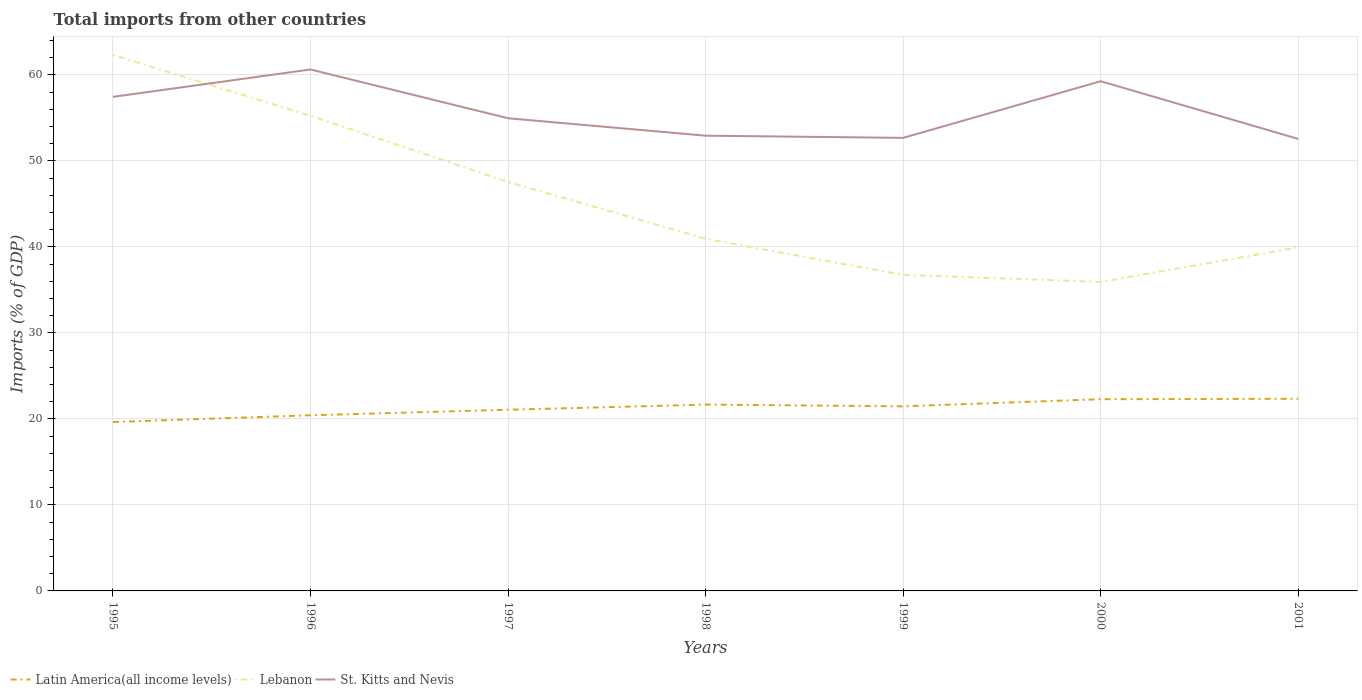Does the line corresponding to Lebanon intersect with the line corresponding to St. Kitts and Nevis?
Ensure brevity in your answer.  Yes. Across all years, what is the maximum total imports in St. Kitts and Nevis?
Keep it short and to the point. 52.56. In which year was the total imports in St. Kitts and Nevis maximum?
Your answer should be compact. 2001. What is the total total imports in St. Kitts and Nevis in the graph?
Your response must be concise. -4.31. What is the difference between the highest and the second highest total imports in Latin America(all income levels)?
Ensure brevity in your answer.  2.7. What is the difference between the highest and the lowest total imports in Lebanon?
Offer a very short reply. 3. Is the total imports in St. Kitts and Nevis strictly greater than the total imports in Lebanon over the years?
Provide a succinct answer. No. How many years are there in the graph?
Your answer should be very brief. 7. Where does the legend appear in the graph?
Make the answer very short. Bottom left. How many legend labels are there?
Your response must be concise. 3. What is the title of the graph?
Your answer should be compact. Total imports from other countries. What is the label or title of the Y-axis?
Provide a short and direct response. Imports (% of GDP). What is the Imports (% of GDP) of Latin America(all income levels) in 1995?
Ensure brevity in your answer.  19.64. What is the Imports (% of GDP) of Lebanon in 1995?
Provide a short and direct response. 62.33. What is the Imports (% of GDP) of St. Kitts and Nevis in 1995?
Your response must be concise. 57.45. What is the Imports (% of GDP) in Latin America(all income levels) in 1996?
Ensure brevity in your answer.  20.43. What is the Imports (% of GDP) of Lebanon in 1996?
Offer a terse response. 55.25. What is the Imports (% of GDP) in St. Kitts and Nevis in 1996?
Make the answer very short. 60.64. What is the Imports (% of GDP) in Latin America(all income levels) in 1997?
Your answer should be very brief. 21.07. What is the Imports (% of GDP) in Lebanon in 1997?
Offer a terse response. 47.55. What is the Imports (% of GDP) in St. Kitts and Nevis in 1997?
Make the answer very short. 54.96. What is the Imports (% of GDP) in Latin America(all income levels) in 1998?
Your answer should be very brief. 21.67. What is the Imports (% of GDP) in Lebanon in 1998?
Ensure brevity in your answer.  40.95. What is the Imports (% of GDP) in St. Kitts and Nevis in 1998?
Keep it short and to the point. 52.94. What is the Imports (% of GDP) in Latin America(all income levels) in 1999?
Offer a very short reply. 21.47. What is the Imports (% of GDP) in Lebanon in 1999?
Provide a short and direct response. 36.75. What is the Imports (% of GDP) of St. Kitts and Nevis in 1999?
Offer a very short reply. 52.68. What is the Imports (% of GDP) of Latin America(all income levels) in 2000?
Ensure brevity in your answer.  22.3. What is the Imports (% of GDP) of Lebanon in 2000?
Provide a short and direct response. 35.94. What is the Imports (% of GDP) of St. Kitts and Nevis in 2000?
Ensure brevity in your answer.  59.27. What is the Imports (% of GDP) of Latin America(all income levels) in 2001?
Offer a very short reply. 22.34. What is the Imports (% of GDP) of Lebanon in 2001?
Offer a terse response. 39.95. What is the Imports (% of GDP) in St. Kitts and Nevis in 2001?
Offer a terse response. 52.56. Across all years, what is the maximum Imports (% of GDP) of Latin America(all income levels)?
Provide a short and direct response. 22.34. Across all years, what is the maximum Imports (% of GDP) in Lebanon?
Make the answer very short. 62.33. Across all years, what is the maximum Imports (% of GDP) of St. Kitts and Nevis?
Offer a terse response. 60.64. Across all years, what is the minimum Imports (% of GDP) in Latin America(all income levels)?
Provide a short and direct response. 19.64. Across all years, what is the minimum Imports (% of GDP) in Lebanon?
Your answer should be very brief. 35.94. Across all years, what is the minimum Imports (% of GDP) of St. Kitts and Nevis?
Make the answer very short. 52.56. What is the total Imports (% of GDP) of Latin America(all income levels) in the graph?
Give a very brief answer. 148.91. What is the total Imports (% of GDP) of Lebanon in the graph?
Offer a terse response. 318.73. What is the total Imports (% of GDP) in St. Kitts and Nevis in the graph?
Make the answer very short. 390.51. What is the difference between the Imports (% of GDP) in Latin America(all income levels) in 1995 and that in 1996?
Offer a terse response. -0.78. What is the difference between the Imports (% of GDP) in Lebanon in 1995 and that in 1996?
Your response must be concise. 7.08. What is the difference between the Imports (% of GDP) in St. Kitts and Nevis in 1995 and that in 1996?
Ensure brevity in your answer.  -3.18. What is the difference between the Imports (% of GDP) of Latin America(all income levels) in 1995 and that in 1997?
Offer a very short reply. -1.43. What is the difference between the Imports (% of GDP) of Lebanon in 1995 and that in 1997?
Ensure brevity in your answer.  14.77. What is the difference between the Imports (% of GDP) of St. Kitts and Nevis in 1995 and that in 1997?
Keep it short and to the point. 2.49. What is the difference between the Imports (% of GDP) of Latin America(all income levels) in 1995 and that in 1998?
Your answer should be very brief. -2.02. What is the difference between the Imports (% of GDP) in Lebanon in 1995 and that in 1998?
Provide a short and direct response. 21.38. What is the difference between the Imports (% of GDP) in St. Kitts and Nevis in 1995 and that in 1998?
Your response must be concise. 4.52. What is the difference between the Imports (% of GDP) of Latin America(all income levels) in 1995 and that in 1999?
Your answer should be compact. -1.82. What is the difference between the Imports (% of GDP) of Lebanon in 1995 and that in 1999?
Make the answer very short. 25.58. What is the difference between the Imports (% of GDP) of St. Kitts and Nevis in 1995 and that in 1999?
Provide a short and direct response. 4.77. What is the difference between the Imports (% of GDP) in Latin America(all income levels) in 1995 and that in 2000?
Keep it short and to the point. -2.65. What is the difference between the Imports (% of GDP) in Lebanon in 1995 and that in 2000?
Provide a short and direct response. 26.39. What is the difference between the Imports (% of GDP) in St. Kitts and Nevis in 1995 and that in 2000?
Ensure brevity in your answer.  -1.82. What is the difference between the Imports (% of GDP) in Latin America(all income levels) in 1995 and that in 2001?
Offer a terse response. -2.7. What is the difference between the Imports (% of GDP) in Lebanon in 1995 and that in 2001?
Keep it short and to the point. 22.38. What is the difference between the Imports (% of GDP) in St. Kitts and Nevis in 1995 and that in 2001?
Offer a terse response. 4.89. What is the difference between the Imports (% of GDP) of Latin America(all income levels) in 1996 and that in 1997?
Keep it short and to the point. -0.64. What is the difference between the Imports (% of GDP) of Lebanon in 1996 and that in 1997?
Your answer should be very brief. 7.7. What is the difference between the Imports (% of GDP) of St. Kitts and Nevis in 1996 and that in 1997?
Give a very brief answer. 5.67. What is the difference between the Imports (% of GDP) in Latin America(all income levels) in 1996 and that in 1998?
Keep it short and to the point. -1.24. What is the difference between the Imports (% of GDP) of Lebanon in 1996 and that in 1998?
Give a very brief answer. 14.3. What is the difference between the Imports (% of GDP) in St. Kitts and Nevis in 1996 and that in 1998?
Ensure brevity in your answer.  7.7. What is the difference between the Imports (% of GDP) in Latin America(all income levels) in 1996 and that in 1999?
Your answer should be compact. -1.04. What is the difference between the Imports (% of GDP) of Lebanon in 1996 and that in 1999?
Provide a short and direct response. 18.5. What is the difference between the Imports (% of GDP) of St. Kitts and Nevis in 1996 and that in 1999?
Make the answer very short. 7.95. What is the difference between the Imports (% of GDP) of Latin America(all income levels) in 1996 and that in 2000?
Make the answer very short. -1.87. What is the difference between the Imports (% of GDP) in Lebanon in 1996 and that in 2000?
Give a very brief answer. 19.31. What is the difference between the Imports (% of GDP) of St. Kitts and Nevis in 1996 and that in 2000?
Your response must be concise. 1.37. What is the difference between the Imports (% of GDP) in Latin America(all income levels) in 1996 and that in 2001?
Provide a succinct answer. -1.92. What is the difference between the Imports (% of GDP) of Lebanon in 1996 and that in 2001?
Ensure brevity in your answer.  15.3. What is the difference between the Imports (% of GDP) of St. Kitts and Nevis in 1996 and that in 2001?
Offer a very short reply. 8.07. What is the difference between the Imports (% of GDP) of Latin America(all income levels) in 1997 and that in 1998?
Offer a very short reply. -0.6. What is the difference between the Imports (% of GDP) of Lebanon in 1997 and that in 1998?
Provide a succinct answer. 6.6. What is the difference between the Imports (% of GDP) in St. Kitts and Nevis in 1997 and that in 1998?
Your answer should be compact. 2.03. What is the difference between the Imports (% of GDP) of Latin America(all income levels) in 1997 and that in 1999?
Provide a short and direct response. -0.4. What is the difference between the Imports (% of GDP) in Lebanon in 1997 and that in 1999?
Your answer should be compact. 10.8. What is the difference between the Imports (% of GDP) in St. Kitts and Nevis in 1997 and that in 1999?
Your answer should be compact. 2.28. What is the difference between the Imports (% of GDP) in Latin America(all income levels) in 1997 and that in 2000?
Your answer should be very brief. -1.23. What is the difference between the Imports (% of GDP) in Lebanon in 1997 and that in 2000?
Provide a short and direct response. 11.62. What is the difference between the Imports (% of GDP) in St. Kitts and Nevis in 1997 and that in 2000?
Your response must be concise. -4.31. What is the difference between the Imports (% of GDP) of Latin America(all income levels) in 1997 and that in 2001?
Your response must be concise. -1.28. What is the difference between the Imports (% of GDP) in Lebanon in 1997 and that in 2001?
Keep it short and to the point. 7.6. What is the difference between the Imports (% of GDP) of St. Kitts and Nevis in 1997 and that in 2001?
Your answer should be compact. 2.4. What is the difference between the Imports (% of GDP) of Latin America(all income levels) in 1998 and that in 1999?
Offer a very short reply. 0.2. What is the difference between the Imports (% of GDP) in Lebanon in 1998 and that in 1999?
Offer a terse response. 4.2. What is the difference between the Imports (% of GDP) in St. Kitts and Nevis in 1998 and that in 1999?
Ensure brevity in your answer.  0.25. What is the difference between the Imports (% of GDP) of Latin America(all income levels) in 1998 and that in 2000?
Your answer should be compact. -0.63. What is the difference between the Imports (% of GDP) of Lebanon in 1998 and that in 2000?
Offer a terse response. 5.02. What is the difference between the Imports (% of GDP) in St. Kitts and Nevis in 1998 and that in 2000?
Offer a very short reply. -6.33. What is the difference between the Imports (% of GDP) in Latin America(all income levels) in 1998 and that in 2001?
Provide a short and direct response. -0.68. What is the difference between the Imports (% of GDP) of Lebanon in 1998 and that in 2001?
Provide a succinct answer. 1. What is the difference between the Imports (% of GDP) in St. Kitts and Nevis in 1998 and that in 2001?
Offer a very short reply. 0.37. What is the difference between the Imports (% of GDP) of Latin America(all income levels) in 1999 and that in 2000?
Ensure brevity in your answer.  -0.83. What is the difference between the Imports (% of GDP) of Lebanon in 1999 and that in 2000?
Keep it short and to the point. 0.81. What is the difference between the Imports (% of GDP) of St. Kitts and Nevis in 1999 and that in 2000?
Offer a terse response. -6.59. What is the difference between the Imports (% of GDP) in Latin America(all income levels) in 1999 and that in 2001?
Make the answer very short. -0.88. What is the difference between the Imports (% of GDP) of Lebanon in 1999 and that in 2001?
Your response must be concise. -3.2. What is the difference between the Imports (% of GDP) in St. Kitts and Nevis in 1999 and that in 2001?
Your answer should be very brief. 0.12. What is the difference between the Imports (% of GDP) in Latin America(all income levels) in 2000 and that in 2001?
Provide a succinct answer. -0.05. What is the difference between the Imports (% of GDP) in Lebanon in 2000 and that in 2001?
Provide a short and direct response. -4.01. What is the difference between the Imports (% of GDP) of St. Kitts and Nevis in 2000 and that in 2001?
Offer a very short reply. 6.71. What is the difference between the Imports (% of GDP) in Latin America(all income levels) in 1995 and the Imports (% of GDP) in Lebanon in 1996?
Your answer should be very brief. -35.61. What is the difference between the Imports (% of GDP) in Latin America(all income levels) in 1995 and the Imports (% of GDP) in St. Kitts and Nevis in 1996?
Make the answer very short. -41. What is the difference between the Imports (% of GDP) of Lebanon in 1995 and the Imports (% of GDP) of St. Kitts and Nevis in 1996?
Ensure brevity in your answer.  1.69. What is the difference between the Imports (% of GDP) in Latin America(all income levels) in 1995 and the Imports (% of GDP) in Lebanon in 1997?
Your answer should be compact. -27.91. What is the difference between the Imports (% of GDP) in Latin America(all income levels) in 1995 and the Imports (% of GDP) in St. Kitts and Nevis in 1997?
Offer a very short reply. -35.32. What is the difference between the Imports (% of GDP) in Lebanon in 1995 and the Imports (% of GDP) in St. Kitts and Nevis in 1997?
Your answer should be very brief. 7.36. What is the difference between the Imports (% of GDP) of Latin America(all income levels) in 1995 and the Imports (% of GDP) of Lebanon in 1998?
Give a very brief answer. -21.31. What is the difference between the Imports (% of GDP) of Latin America(all income levels) in 1995 and the Imports (% of GDP) of St. Kitts and Nevis in 1998?
Your response must be concise. -33.3. What is the difference between the Imports (% of GDP) in Lebanon in 1995 and the Imports (% of GDP) in St. Kitts and Nevis in 1998?
Keep it short and to the point. 9.39. What is the difference between the Imports (% of GDP) in Latin America(all income levels) in 1995 and the Imports (% of GDP) in Lebanon in 1999?
Ensure brevity in your answer.  -17.11. What is the difference between the Imports (% of GDP) in Latin America(all income levels) in 1995 and the Imports (% of GDP) in St. Kitts and Nevis in 1999?
Make the answer very short. -33.04. What is the difference between the Imports (% of GDP) of Lebanon in 1995 and the Imports (% of GDP) of St. Kitts and Nevis in 1999?
Provide a short and direct response. 9.64. What is the difference between the Imports (% of GDP) in Latin America(all income levels) in 1995 and the Imports (% of GDP) in Lebanon in 2000?
Give a very brief answer. -16.3. What is the difference between the Imports (% of GDP) in Latin America(all income levels) in 1995 and the Imports (% of GDP) in St. Kitts and Nevis in 2000?
Ensure brevity in your answer.  -39.63. What is the difference between the Imports (% of GDP) of Lebanon in 1995 and the Imports (% of GDP) of St. Kitts and Nevis in 2000?
Ensure brevity in your answer.  3.06. What is the difference between the Imports (% of GDP) in Latin America(all income levels) in 1995 and the Imports (% of GDP) in Lebanon in 2001?
Provide a short and direct response. -20.31. What is the difference between the Imports (% of GDP) of Latin America(all income levels) in 1995 and the Imports (% of GDP) of St. Kitts and Nevis in 2001?
Offer a terse response. -32.92. What is the difference between the Imports (% of GDP) of Lebanon in 1995 and the Imports (% of GDP) of St. Kitts and Nevis in 2001?
Your answer should be compact. 9.77. What is the difference between the Imports (% of GDP) in Latin America(all income levels) in 1996 and the Imports (% of GDP) in Lebanon in 1997?
Ensure brevity in your answer.  -27.13. What is the difference between the Imports (% of GDP) in Latin America(all income levels) in 1996 and the Imports (% of GDP) in St. Kitts and Nevis in 1997?
Provide a short and direct response. -34.54. What is the difference between the Imports (% of GDP) of Lebanon in 1996 and the Imports (% of GDP) of St. Kitts and Nevis in 1997?
Keep it short and to the point. 0.29. What is the difference between the Imports (% of GDP) in Latin America(all income levels) in 1996 and the Imports (% of GDP) in Lebanon in 1998?
Your response must be concise. -20.53. What is the difference between the Imports (% of GDP) of Latin America(all income levels) in 1996 and the Imports (% of GDP) of St. Kitts and Nevis in 1998?
Offer a very short reply. -32.51. What is the difference between the Imports (% of GDP) of Lebanon in 1996 and the Imports (% of GDP) of St. Kitts and Nevis in 1998?
Offer a terse response. 2.31. What is the difference between the Imports (% of GDP) of Latin America(all income levels) in 1996 and the Imports (% of GDP) of Lebanon in 1999?
Make the answer very short. -16.32. What is the difference between the Imports (% of GDP) in Latin America(all income levels) in 1996 and the Imports (% of GDP) in St. Kitts and Nevis in 1999?
Give a very brief answer. -32.26. What is the difference between the Imports (% of GDP) of Lebanon in 1996 and the Imports (% of GDP) of St. Kitts and Nevis in 1999?
Make the answer very short. 2.57. What is the difference between the Imports (% of GDP) of Latin America(all income levels) in 1996 and the Imports (% of GDP) of Lebanon in 2000?
Provide a succinct answer. -15.51. What is the difference between the Imports (% of GDP) in Latin America(all income levels) in 1996 and the Imports (% of GDP) in St. Kitts and Nevis in 2000?
Your answer should be very brief. -38.84. What is the difference between the Imports (% of GDP) of Lebanon in 1996 and the Imports (% of GDP) of St. Kitts and Nevis in 2000?
Your answer should be very brief. -4.02. What is the difference between the Imports (% of GDP) in Latin America(all income levels) in 1996 and the Imports (% of GDP) in Lebanon in 2001?
Ensure brevity in your answer.  -19.53. What is the difference between the Imports (% of GDP) in Latin America(all income levels) in 1996 and the Imports (% of GDP) in St. Kitts and Nevis in 2001?
Provide a succinct answer. -32.14. What is the difference between the Imports (% of GDP) of Lebanon in 1996 and the Imports (% of GDP) of St. Kitts and Nevis in 2001?
Give a very brief answer. 2.69. What is the difference between the Imports (% of GDP) in Latin America(all income levels) in 1997 and the Imports (% of GDP) in Lebanon in 1998?
Offer a very short reply. -19.89. What is the difference between the Imports (% of GDP) of Latin America(all income levels) in 1997 and the Imports (% of GDP) of St. Kitts and Nevis in 1998?
Offer a very short reply. -31.87. What is the difference between the Imports (% of GDP) of Lebanon in 1997 and the Imports (% of GDP) of St. Kitts and Nevis in 1998?
Keep it short and to the point. -5.38. What is the difference between the Imports (% of GDP) of Latin America(all income levels) in 1997 and the Imports (% of GDP) of Lebanon in 1999?
Provide a short and direct response. -15.68. What is the difference between the Imports (% of GDP) in Latin America(all income levels) in 1997 and the Imports (% of GDP) in St. Kitts and Nevis in 1999?
Make the answer very short. -31.62. What is the difference between the Imports (% of GDP) in Lebanon in 1997 and the Imports (% of GDP) in St. Kitts and Nevis in 1999?
Make the answer very short. -5.13. What is the difference between the Imports (% of GDP) in Latin America(all income levels) in 1997 and the Imports (% of GDP) in Lebanon in 2000?
Provide a succinct answer. -14.87. What is the difference between the Imports (% of GDP) of Latin America(all income levels) in 1997 and the Imports (% of GDP) of St. Kitts and Nevis in 2000?
Offer a terse response. -38.2. What is the difference between the Imports (% of GDP) of Lebanon in 1997 and the Imports (% of GDP) of St. Kitts and Nevis in 2000?
Keep it short and to the point. -11.72. What is the difference between the Imports (% of GDP) of Latin America(all income levels) in 1997 and the Imports (% of GDP) of Lebanon in 2001?
Provide a short and direct response. -18.88. What is the difference between the Imports (% of GDP) of Latin America(all income levels) in 1997 and the Imports (% of GDP) of St. Kitts and Nevis in 2001?
Your answer should be very brief. -31.5. What is the difference between the Imports (% of GDP) of Lebanon in 1997 and the Imports (% of GDP) of St. Kitts and Nevis in 2001?
Make the answer very short. -5.01. What is the difference between the Imports (% of GDP) of Latin America(all income levels) in 1998 and the Imports (% of GDP) of Lebanon in 1999?
Offer a terse response. -15.08. What is the difference between the Imports (% of GDP) in Latin America(all income levels) in 1998 and the Imports (% of GDP) in St. Kitts and Nevis in 1999?
Offer a very short reply. -31.02. What is the difference between the Imports (% of GDP) in Lebanon in 1998 and the Imports (% of GDP) in St. Kitts and Nevis in 1999?
Ensure brevity in your answer.  -11.73. What is the difference between the Imports (% of GDP) of Latin America(all income levels) in 1998 and the Imports (% of GDP) of Lebanon in 2000?
Ensure brevity in your answer.  -14.27. What is the difference between the Imports (% of GDP) of Latin America(all income levels) in 1998 and the Imports (% of GDP) of St. Kitts and Nevis in 2000?
Provide a succinct answer. -37.6. What is the difference between the Imports (% of GDP) of Lebanon in 1998 and the Imports (% of GDP) of St. Kitts and Nevis in 2000?
Make the answer very short. -18.32. What is the difference between the Imports (% of GDP) in Latin America(all income levels) in 1998 and the Imports (% of GDP) in Lebanon in 2001?
Make the answer very short. -18.29. What is the difference between the Imports (% of GDP) of Latin America(all income levels) in 1998 and the Imports (% of GDP) of St. Kitts and Nevis in 2001?
Provide a succinct answer. -30.9. What is the difference between the Imports (% of GDP) of Lebanon in 1998 and the Imports (% of GDP) of St. Kitts and Nevis in 2001?
Offer a terse response. -11.61. What is the difference between the Imports (% of GDP) in Latin America(all income levels) in 1999 and the Imports (% of GDP) in Lebanon in 2000?
Ensure brevity in your answer.  -14.47. What is the difference between the Imports (% of GDP) of Latin America(all income levels) in 1999 and the Imports (% of GDP) of St. Kitts and Nevis in 2000?
Provide a short and direct response. -37.8. What is the difference between the Imports (% of GDP) in Lebanon in 1999 and the Imports (% of GDP) in St. Kitts and Nevis in 2000?
Ensure brevity in your answer.  -22.52. What is the difference between the Imports (% of GDP) of Latin America(all income levels) in 1999 and the Imports (% of GDP) of Lebanon in 2001?
Your response must be concise. -18.49. What is the difference between the Imports (% of GDP) of Latin America(all income levels) in 1999 and the Imports (% of GDP) of St. Kitts and Nevis in 2001?
Your answer should be compact. -31.1. What is the difference between the Imports (% of GDP) of Lebanon in 1999 and the Imports (% of GDP) of St. Kitts and Nevis in 2001?
Provide a succinct answer. -15.81. What is the difference between the Imports (% of GDP) of Latin America(all income levels) in 2000 and the Imports (% of GDP) of Lebanon in 2001?
Keep it short and to the point. -17.66. What is the difference between the Imports (% of GDP) of Latin America(all income levels) in 2000 and the Imports (% of GDP) of St. Kitts and Nevis in 2001?
Provide a succinct answer. -30.27. What is the difference between the Imports (% of GDP) of Lebanon in 2000 and the Imports (% of GDP) of St. Kitts and Nevis in 2001?
Ensure brevity in your answer.  -16.63. What is the average Imports (% of GDP) in Latin America(all income levels) per year?
Offer a very short reply. 21.27. What is the average Imports (% of GDP) of Lebanon per year?
Your answer should be very brief. 45.53. What is the average Imports (% of GDP) of St. Kitts and Nevis per year?
Make the answer very short. 55.79. In the year 1995, what is the difference between the Imports (% of GDP) in Latin America(all income levels) and Imports (% of GDP) in Lebanon?
Your answer should be very brief. -42.69. In the year 1995, what is the difference between the Imports (% of GDP) in Latin America(all income levels) and Imports (% of GDP) in St. Kitts and Nevis?
Your answer should be very brief. -37.81. In the year 1995, what is the difference between the Imports (% of GDP) of Lebanon and Imports (% of GDP) of St. Kitts and Nevis?
Ensure brevity in your answer.  4.88. In the year 1996, what is the difference between the Imports (% of GDP) of Latin America(all income levels) and Imports (% of GDP) of Lebanon?
Ensure brevity in your answer.  -34.82. In the year 1996, what is the difference between the Imports (% of GDP) of Latin America(all income levels) and Imports (% of GDP) of St. Kitts and Nevis?
Your answer should be compact. -40.21. In the year 1996, what is the difference between the Imports (% of GDP) of Lebanon and Imports (% of GDP) of St. Kitts and Nevis?
Ensure brevity in your answer.  -5.39. In the year 1997, what is the difference between the Imports (% of GDP) of Latin America(all income levels) and Imports (% of GDP) of Lebanon?
Make the answer very short. -26.49. In the year 1997, what is the difference between the Imports (% of GDP) of Latin America(all income levels) and Imports (% of GDP) of St. Kitts and Nevis?
Offer a terse response. -33.9. In the year 1997, what is the difference between the Imports (% of GDP) in Lebanon and Imports (% of GDP) in St. Kitts and Nevis?
Make the answer very short. -7.41. In the year 1998, what is the difference between the Imports (% of GDP) in Latin America(all income levels) and Imports (% of GDP) in Lebanon?
Ensure brevity in your answer.  -19.29. In the year 1998, what is the difference between the Imports (% of GDP) in Latin America(all income levels) and Imports (% of GDP) in St. Kitts and Nevis?
Provide a succinct answer. -31.27. In the year 1998, what is the difference between the Imports (% of GDP) of Lebanon and Imports (% of GDP) of St. Kitts and Nevis?
Your answer should be compact. -11.98. In the year 1999, what is the difference between the Imports (% of GDP) in Latin America(all income levels) and Imports (% of GDP) in Lebanon?
Give a very brief answer. -15.28. In the year 1999, what is the difference between the Imports (% of GDP) in Latin America(all income levels) and Imports (% of GDP) in St. Kitts and Nevis?
Provide a short and direct response. -31.22. In the year 1999, what is the difference between the Imports (% of GDP) of Lebanon and Imports (% of GDP) of St. Kitts and Nevis?
Keep it short and to the point. -15.93. In the year 2000, what is the difference between the Imports (% of GDP) in Latin America(all income levels) and Imports (% of GDP) in Lebanon?
Provide a short and direct response. -13.64. In the year 2000, what is the difference between the Imports (% of GDP) of Latin America(all income levels) and Imports (% of GDP) of St. Kitts and Nevis?
Ensure brevity in your answer.  -36.97. In the year 2000, what is the difference between the Imports (% of GDP) in Lebanon and Imports (% of GDP) in St. Kitts and Nevis?
Ensure brevity in your answer.  -23.33. In the year 2001, what is the difference between the Imports (% of GDP) of Latin America(all income levels) and Imports (% of GDP) of Lebanon?
Offer a very short reply. -17.61. In the year 2001, what is the difference between the Imports (% of GDP) in Latin America(all income levels) and Imports (% of GDP) in St. Kitts and Nevis?
Offer a terse response. -30.22. In the year 2001, what is the difference between the Imports (% of GDP) in Lebanon and Imports (% of GDP) in St. Kitts and Nevis?
Provide a short and direct response. -12.61. What is the ratio of the Imports (% of GDP) in Latin America(all income levels) in 1995 to that in 1996?
Your answer should be very brief. 0.96. What is the ratio of the Imports (% of GDP) in Lebanon in 1995 to that in 1996?
Give a very brief answer. 1.13. What is the ratio of the Imports (% of GDP) in St. Kitts and Nevis in 1995 to that in 1996?
Make the answer very short. 0.95. What is the ratio of the Imports (% of GDP) in Latin America(all income levels) in 1995 to that in 1997?
Keep it short and to the point. 0.93. What is the ratio of the Imports (% of GDP) of Lebanon in 1995 to that in 1997?
Offer a very short reply. 1.31. What is the ratio of the Imports (% of GDP) in St. Kitts and Nevis in 1995 to that in 1997?
Provide a short and direct response. 1.05. What is the ratio of the Imports (% of GDP) of Latin America(all income levels) in 1995 to that in 1998?
Your answer should be compact. 0.91. What is the ratio of the Imports (% of GDP) of Lebanon in 1995 to that in 1998?
Make the answer very short. 1.52. What is the ratio of the Imports (% of GDP) of St. Kitts and Nevis in 1995 to that in 1998?
Ensure brevity in your answer.  1.09. What is the ratio of the Imports (% of GDP) in Latin America(all income levels) in 1995 to that in 1999?
Keep it short and to the point. 0.92. What is the ratio of the Imports (% of GDP) of Lebanon in 1995 to that in 1999?
Keep it short and to the point. 1.7. What is the ratio of the Imports (% of GDP) of St. Kitts and Nevis in 1995 to that in 1999?
Your answer should be compact. 1.09. What is the ratio of the Imports (% of GDP) in Latin America(all income levels) in 1995 to that in 2000?
Offer a terse response. 0.88. What is the ratio of the Imports (% of GDP) in Lebanon in 1995 to that in 2000?
Offer a very short reply. 1.73. What is the ratio of the Imports (% of GDP) in St. Kitts and Nevis in 1995 to that in 2000?
Offer a very short reply. 0.97. What is the ratio of the Imports (% of GDP) in Latin America(all income levels) in 1995 to that in 2001?
Your response must be concise. 0.88. What is the ratio of the Imports (% of GDP) in Lebanon in 1995 to that in 2001?
Keep it short and to the point. 1.56. What is the ratio of the Imports (% of GDP) in St. Kitts and Nevis in 1995 to that in 2001?
Your response must be concise. 1.09. What is the ratio of the Imports (% of GDP) of Latin America(all income levels) in 1996 to that in 1997?
Keep it short and to the point. 0.97. What is the ratio of the Imports (% of GDP) in Lebanon in 1996 to that in 1997?
Offer a very short reply. 1.16. What is the ratio of the Imports (% of GDP) of St. Kitts and Nevis in 1996 to that in 1997?
Your response must be concise. 1.1. What is the ratio of the Imports (% of GDP) of Latin America(all income levels) in 1996 to that in 1998?
Ensure brevity in your answer.  0.94. What is the ratio of the Imports (% of GDP) in Lebanon in 1996 to that in 1998?
Your response must be concise. 1.35. What is the ratio of the Imports (% of GDP) of St. Kitts and Nevis in 1996 to that in 1998?
Offer a terse response. 1.15. What is the ratio of the Imports (% of GDP) of Latin America(all income levels) in 1996 to that in 1999?
Keep it short and to the point. 0.95. What is the ratio of the Imports (% of GDP) of Lebanon in 1996 to that in 1999?
Provide a succinct answer. 1.5. What is the ratio of the Imports (% of GDP) of St. Kitts and Nevis in 1996 to that in 1999?
Your response must be concise. 1.15. What is the ratio of the Imports (% of GDP) of Latin America(all income levels) in 1996 to that in 2000?
Your answer should be very brief. 0.92. What is the ratio of the Imports (% of GDP) in Lebanon in 1996 to that in 2000?
Ensure brevity in your answer.  1.54. What is the ratio of the Imports (% of GDP) of St. Kitts and Nevis in 1996 to that in 2000?
Provide a short and direct response. 1.02. What is the ratio of the Imports (% of GDP) in Latin America(all income levels) in 1996 to that in 2001?
Make the answer very short. 0.91. What is the ratio of the Imports (% of GDP) in Lebanon in 1996 to that in 2001?
Make the answer very short. 1.38. What is the ratio of the Imports (% of GDP) of St. Kitts and Nevis in 1996 to that in 2001?
Provide a short and direct response. 1.15. What is the ratio of the Imports (% of GDP) of Latin America(all income levels) in 1997 to that in 1998?
Keep it short and to the point. 0.97. What is the ratio of the Imports (% of GDP) in Lebanon in 1997 to that in 1998?
Your response must be concise. 1.16. What is the ratio of the Imports (% of GDP) in St. Kitts and Nevis in 1997 to that in 1998?
Give a very brief answer. 1.04. What is the ratio of the Imports (% of GDP) of Latin America(all income levels) in 1997 to that in 1999?
Provide a short and direct response. 0.98. What is the ratio of the Imports (% of GDP) in Lebanon in 1997 to that in 1999?
Offer a very short reply. 1.29. What is the ratio of the Imports (% of GDP) in St. Kitts and Nevis in 1997 to that in 1999?
Offer a very short reply. 1.04. What is the ratio of the Imports (% of GDP) in Latin America(all income levels) in 1997 to that in 2000?
Keep it short and to the point. 0.94. What is the ratio of the Imports (% of GDP) in Lebanon in 1997 to that in 2000?
Give a very brief answer. 1.32. What is the ratio of the Imports (% of GDP) in St. Kitts and Nevis in 1997 to that in 2000?
Give a very brief answer. 0.93. What is the ratio of the Imports (% of GDP) in Latin America(all income levels) in 1997 to that in 2001?
Give a very brief answer. 0.94. What is the ratio of the Imports (% of GDP) of Lebanon in 1997 to that in 2001?
Ensure brevity in your answer.  1.19. What is the ratio of the Imports (% of GDP) in St. Kitts and Nevis in 1997 to that in 2001?
Your answer should be compact. 1.05. What is the ratio of the Imports (% of GDP) of Latin America(all income levels) in 1998 to that in 1999?
Give a very brief answer. 1.01. What is the ratio of the Imports (% of GDP) in Lebanon in 1998 to that in 1999?
Offer a very short reply. 1.11. What is the ratio of the Imports (% of GDP) of Latin America(all income levels) in 1998 to that in 2000?
Make the answer very short. 0.97. What is the ratio of the Imports (% of GDP) of Lebanon in 1998 to that in 2000?
Ensure brevity in your answer.  1.14. What is the ratio of the Imports (% of GDP) of St. Kitts and Nevis in 1998 to that in 2000?
Your answer should be compact. 0.89. What is the ratio of the Imports (% of GDP) in Latin America(all income levels) in 1998 to that in 2001?
Provide a succinct answer. 0.97. What is the ratio of the Imports (% of GDP) of Lebanon in 1998 to that in 2001?
Your response must be concise. 1.03. What is the ratio of the Imports (% of GDP) in St. Kitts and Nevis in 1998 to that in 2001?
Provide a succinct answer. 1.01. What is the ratio of the Imports (% of GDP) in Latin America(all income levels) in 1999 to that in 2000?
Give a very brief answer. 0.96. What is the ratio of the Imports (% of GDP) in Lebanon in 1999 to that in 2000?
Ensure brevity in your answer.  1.02. What is the ratio of the Imports (% of GDP) in St. Kitts and Nevis in 1999 to that in 2000?
Ensure brevity in your answer.  0.89. What is the ratio of the Imports (% of GDP) in Latin America(all income levels) in 1999 to that in 2001?
Keep it short and to the point. 0.96. What is the ratio of the Imports (% of GDP) of Lebanon in 1999 to that in 2001?
Ensure brevity in your answer.  0.92. What is the ratio of the Imports (% of GDP) of Latin America(all income levels) in 2000 to that in 2001?
Your answer should be very brief. 1. What is the ratio of the Imports (% of GDP) in Lebanon in 2000 to that in 2001?
Your response must be concise. 0.9. What is the ratio of the Imports (% of GDP) of St. Kitts and Nevis in 2000 to that in 2001?
Make the answer very short. 1.13. What is the difference between the highest and the second highest Imports (% of GDP) in Latin America(all income levels)?
Ensure brevity in your answer.  0.05. What is the difference between the highest and the second highest Imports (% of GDP) in Lebanon?
Give a very brief answer. 7.08. What is the difference between the highest and the second highest Imports (% of GDP) of St. Kitts and Nevis?
Make the answer very short. 1.37. What is the difference between the highest and the lowest Imports (% of GDP) in Latin America(all income levels)?
Offer a terse response. 2.7. What is the difference between the highest and the lowest Imports (% of GDP) of Lebanon?
Your answer should be very brief. 26.39. What is the difference between the highest and the lowest Imports (% of GDP) of St. Kitts and Nevis?
Provide a short and direct response. 8.07. 